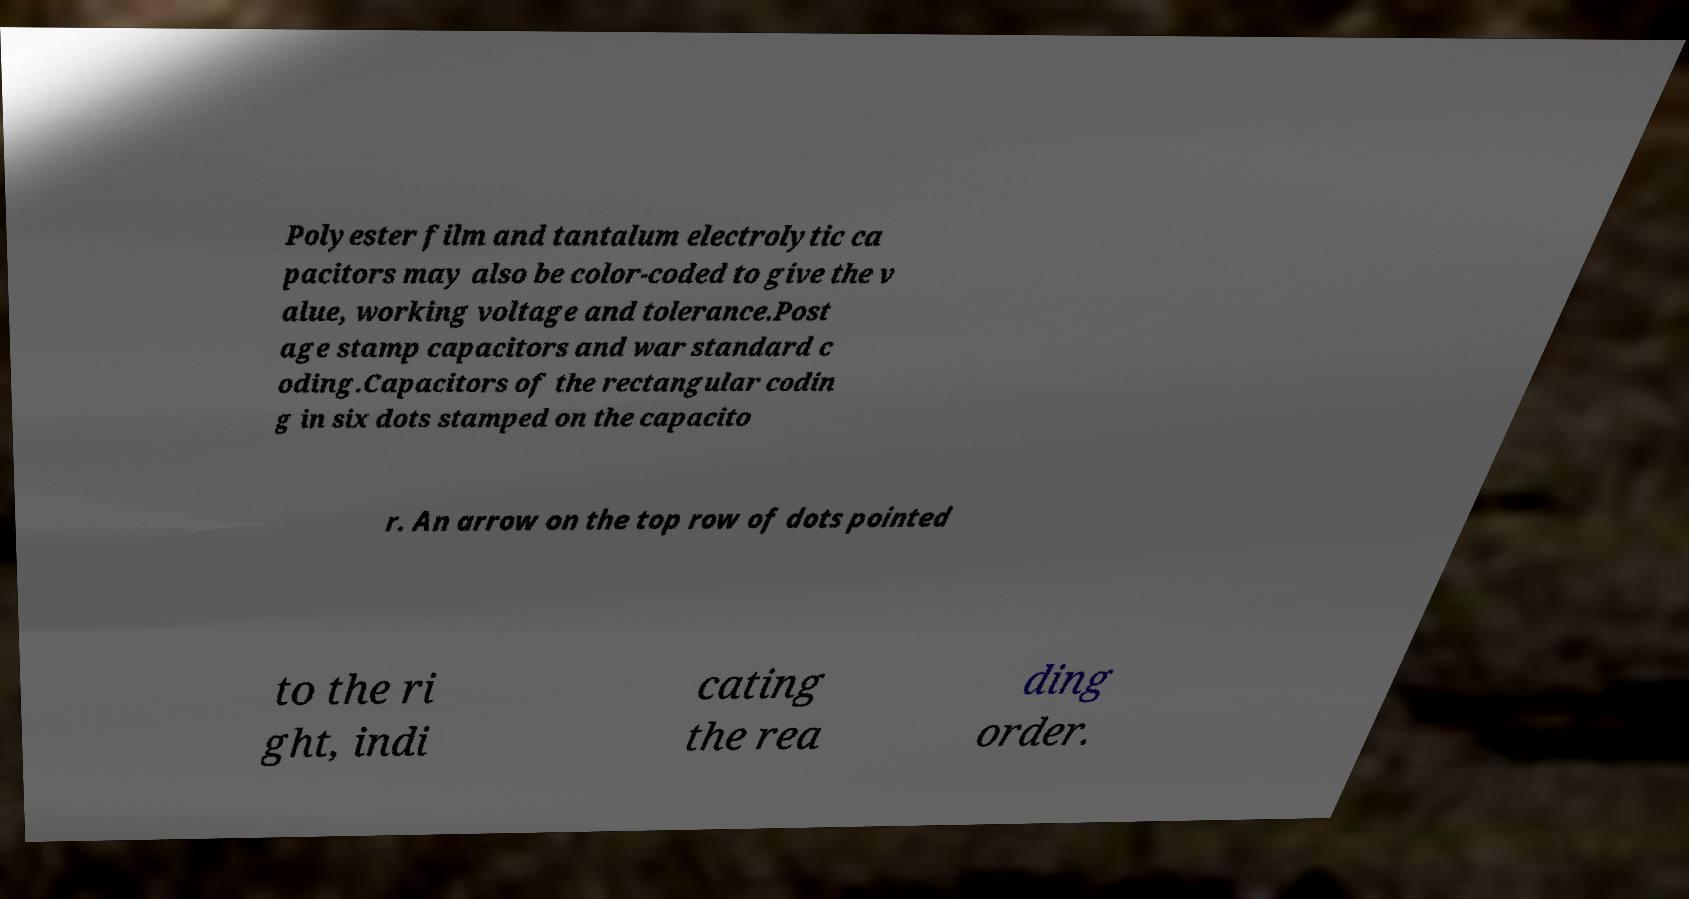Please read and relay the text visible in this image. What does it say? Polyester film and tantalum electrolytic ca pacitors may also be color-coded to give the v alue, working voltage and tolerance.Post age stamp capacitors and war standard c oding.Capacitors of the rectangular codin g in six dots stamped on the capacito r. An arrow on the top row of dots pointed to the ri ght, indi cating the rea ding order. 